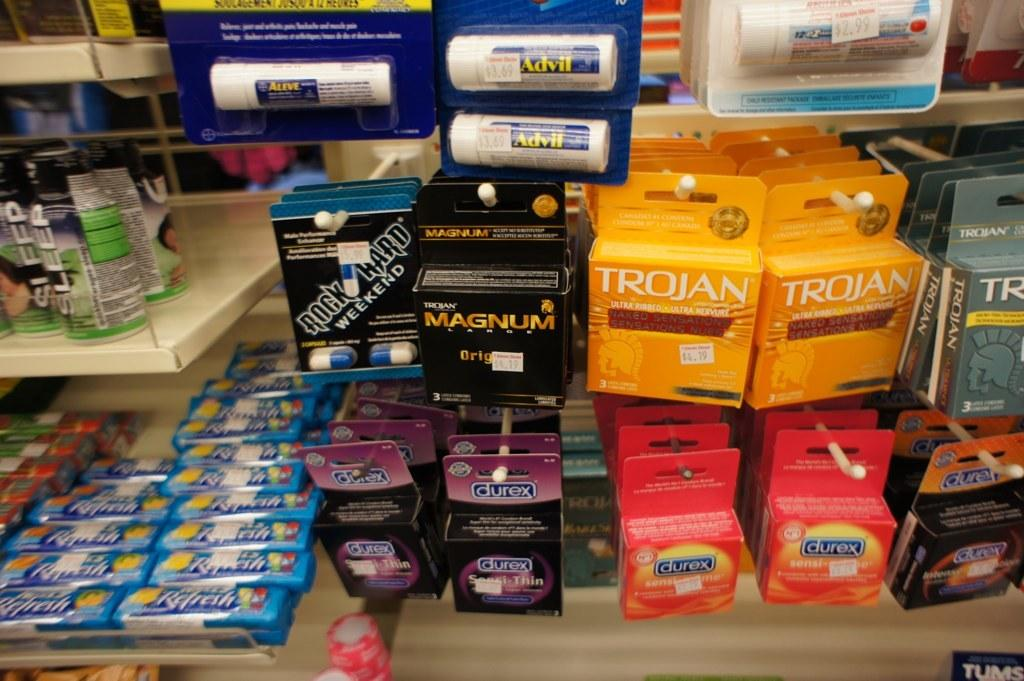<image>
Summarize the visual content of the image. A store display that is showing several products including Aleve, durex, and Trojan. 